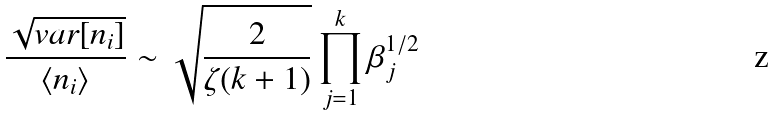<formula> <loc_0><loc_0><loc_500><loc_500>\frac { \sqrt { v a r [ n _ { i } ] } } { \langle n _ { i } \rangle } \sim \sqrt { \frac { 2 } { \zeta ( k + 1 ) } } \prod _ { j = 1 } ^ { k } \beta _ { j } ^ { 1 / 2 }</formula> 